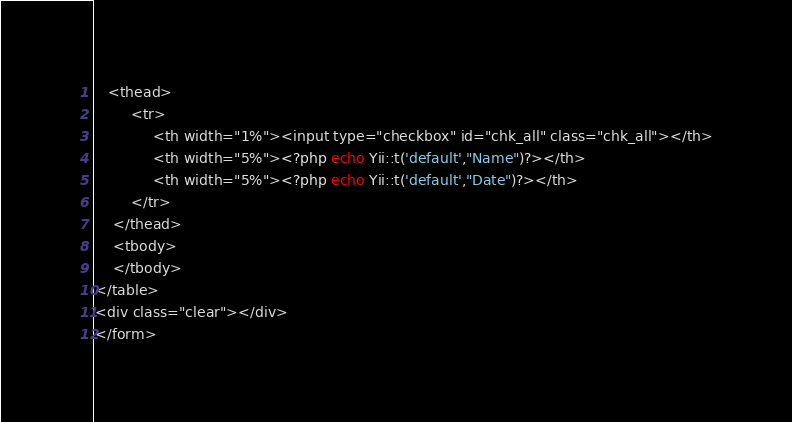Convert code to text. <code><loc_0><loc_0><loc_500><loc_500><_PHP_>   <thead>
        <tr>
			 <th width="1%"><input type="checkbox" id="chk_all" class="chk_all"></th>
			 <th width="5%"><?php echo Yii::t('default',"Name")?></th>			 
			 <th width="5%"><?php echo Yii::t('default',"Date")?></th>
        </tr>
    </thead>
    <tbody>    
    </tbody>
</table>
<div class="clear"></div>
</form></code> 